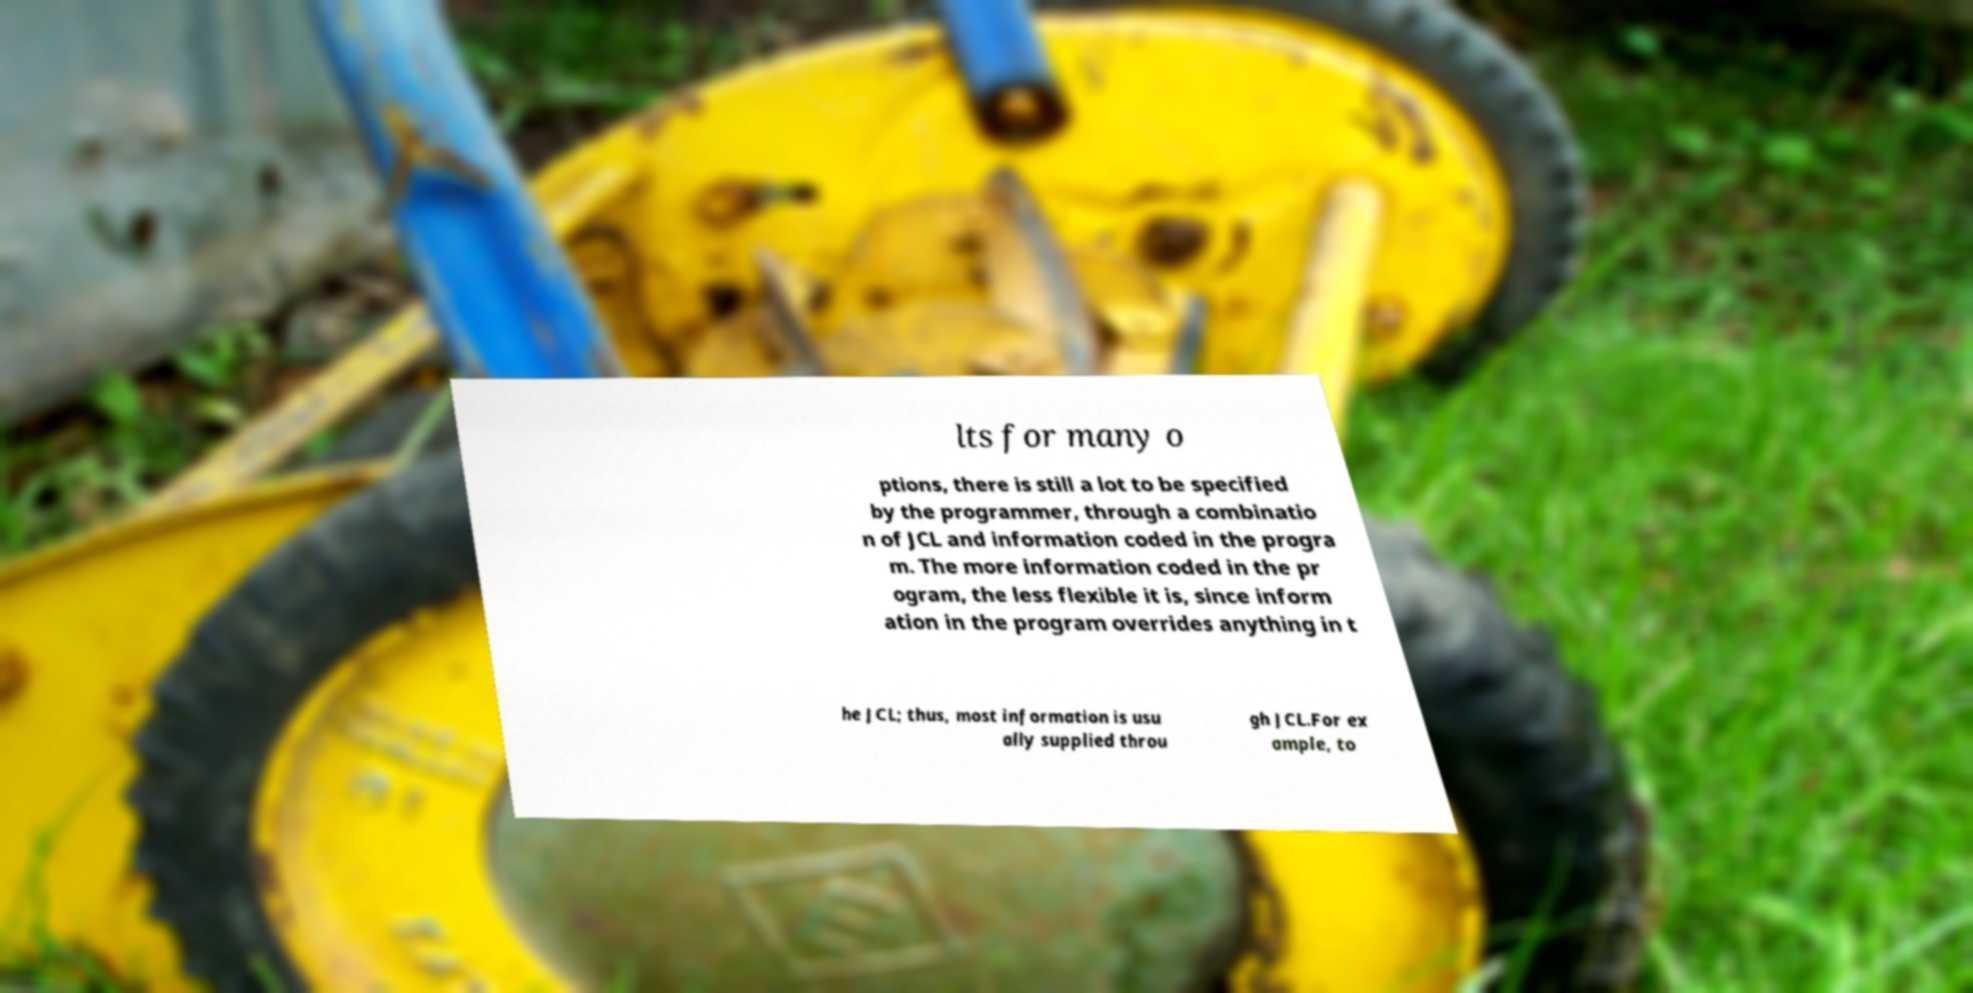What messages or text are displayed in this image? I need them in a readable, typed format. lts for many o ptions, there is still a lot to be specified by the programmer, through a combinatio n of JCL and information coded in the progra m. The more information coded in the pr ogram, the less flexible it is, since inform ation in the program overrides anything in t he JCL; thus, most information is usu ally supplied throu gh JCL.For ex ample, to 